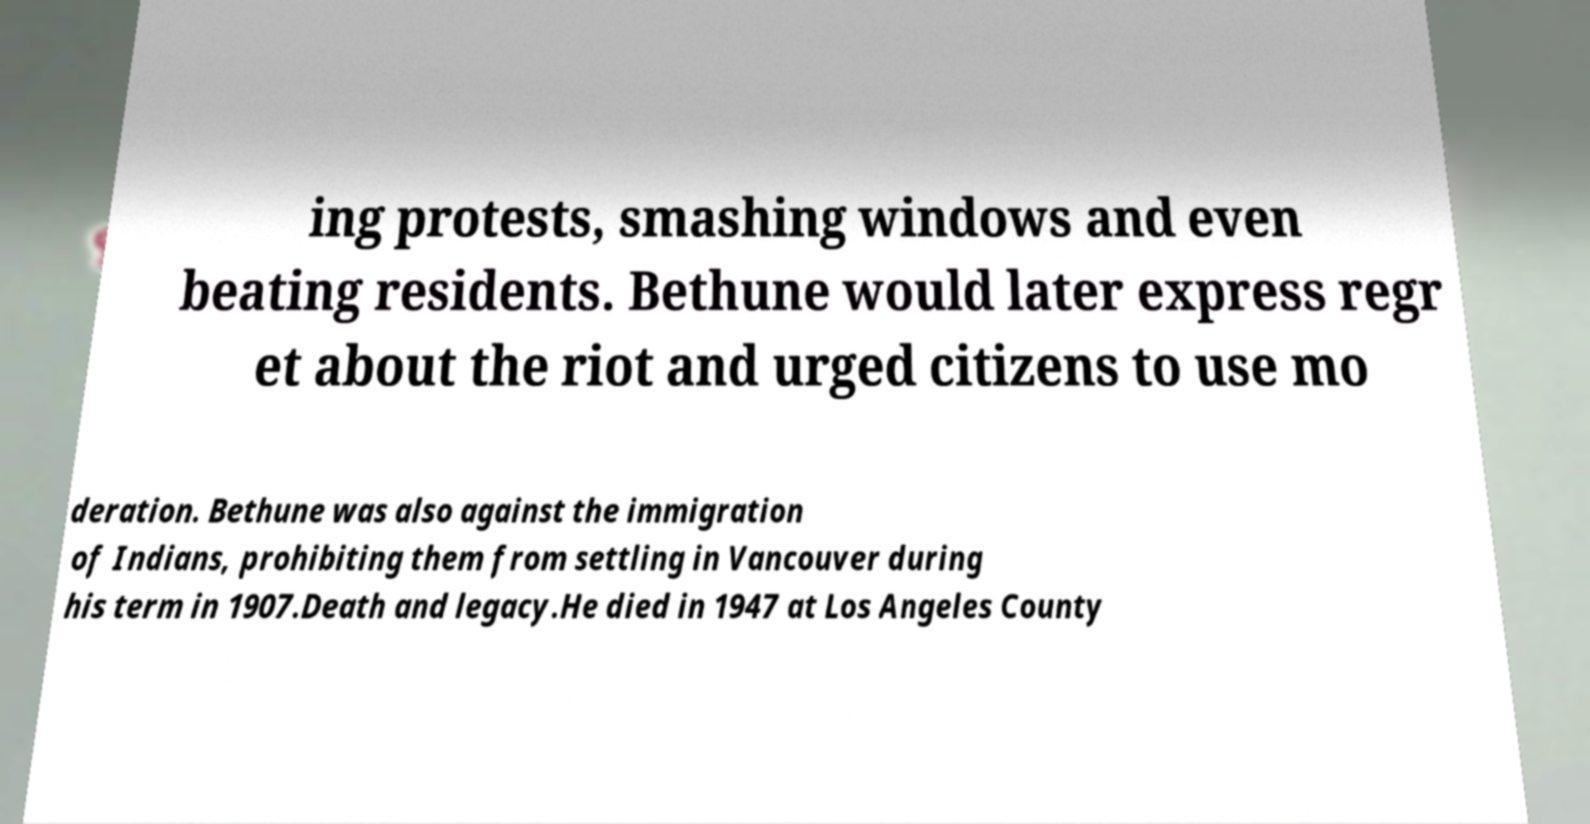Can you accurately transcribe the text from the provided image for me? ing protests, smashing windows and even beating residents. Bethune would later express regr et about the riot and urged citizens to use mo deration. Bethune was also against the immigration of Indians, prohibiting them from settling in Vancouver during his term in 1907.Death and legacy.He died in 1947 at Los Angeles County 